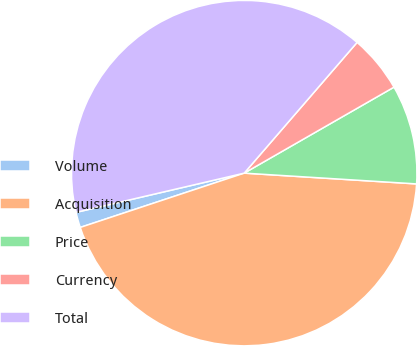Convert chart to OTSL. <chart><loc_0><loc_0><loc_500><loc_500><pie_chart><fcel>Volume<fcel>Acquisition<fcel>Price<fcel>Currency<fcel>Total<nl><fcel>1.44%<fcel>43.92%<fcel>9.29%<fcel>5.37%<fcel>39.99%<nl></chart> 